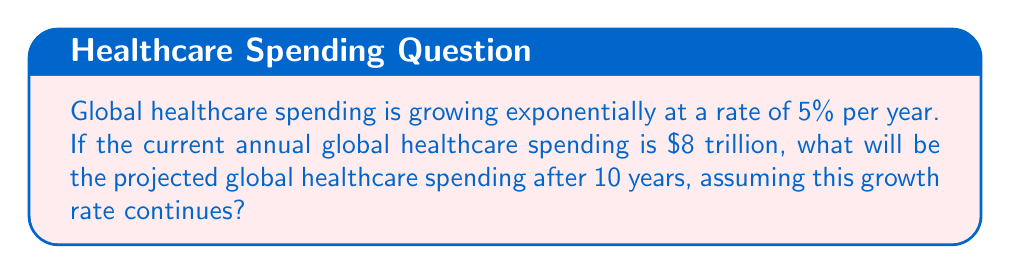Help me with this question. To solve this problem, we'll use the exponential growth formula:

$$A = P(1 + r)^t$$

Where:
$A$ = Final amount
$P$ = Initial principal balance
$r$ = Annual growth rate (as a decimal)
$t$ = Number of years

Given:
$P = 8$ trillion
$r = 5\% = 0.05$
$t = 10$ years

Let's substitute these values into the formula:

$$A = 8(1 + 0.05)^{10}$$

Now, let's solve step-by-step:

1) First, calculate $(1 + 0.05)^{10}$:
   $$(1.05)^{10} \approx 1.6288946$$

2) Multiply this result by the initial amount:
   $$A = 8 \times 1.6288946 \approx 13.0311568$$

3) Round to two decimal places for currency:
   $$A \approx 13.03$$

Therefore, the projected global healthcare spending after 10 years will be approximately $13.03 trillion.
Answer: $13.03 trillion 